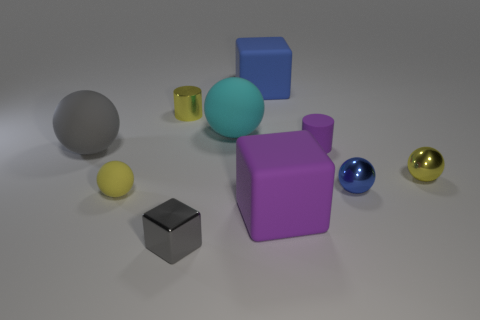Subtract all large gray spheres. How many spheres are left? 4 Subtract all cyan spheres. How many spheres are left? 4 Subtract all purple spheres. Subtract all cyan cylinders. How many spheres are left? 5 Subtract all cylinders. How many objects are left? 8 Subtract all green shiny spheres. Subtract all small purple things. How many objects are left? 9 Add 7 blocks. How many blocks are left? 10 Add 7 big brown metal cubes. How many big brown metal cubes exist? 7 Subtract 1 blue balls. How many objects are left? 9 